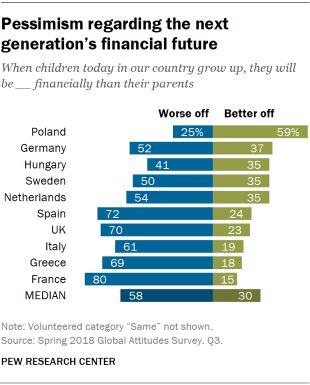List a handful of essential elements in this visual. According to recent surveys, a significant portion of the population of Spain believes that today's children will be better off financially than their parents when they grow up. The median data is approximately 1.21875. 